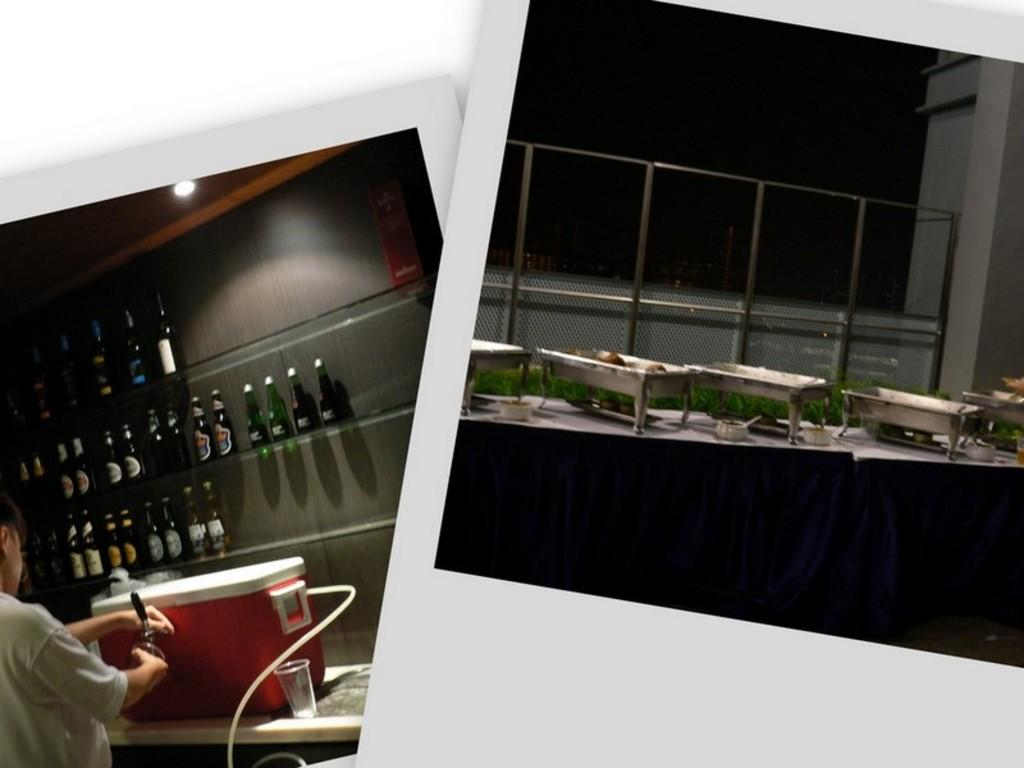What type of artwork is depicted in the image? The image is a collage. What can be seen in the collage? There are pictures of bottles and food items in dishes in the collage. What type of cake is shown in the image? There is no cake present in the image; the collage features pictures of bottles and food items in dishes. In what position is the cake displayed in the image? As there is no cake in the image, we cannot determine its position. 